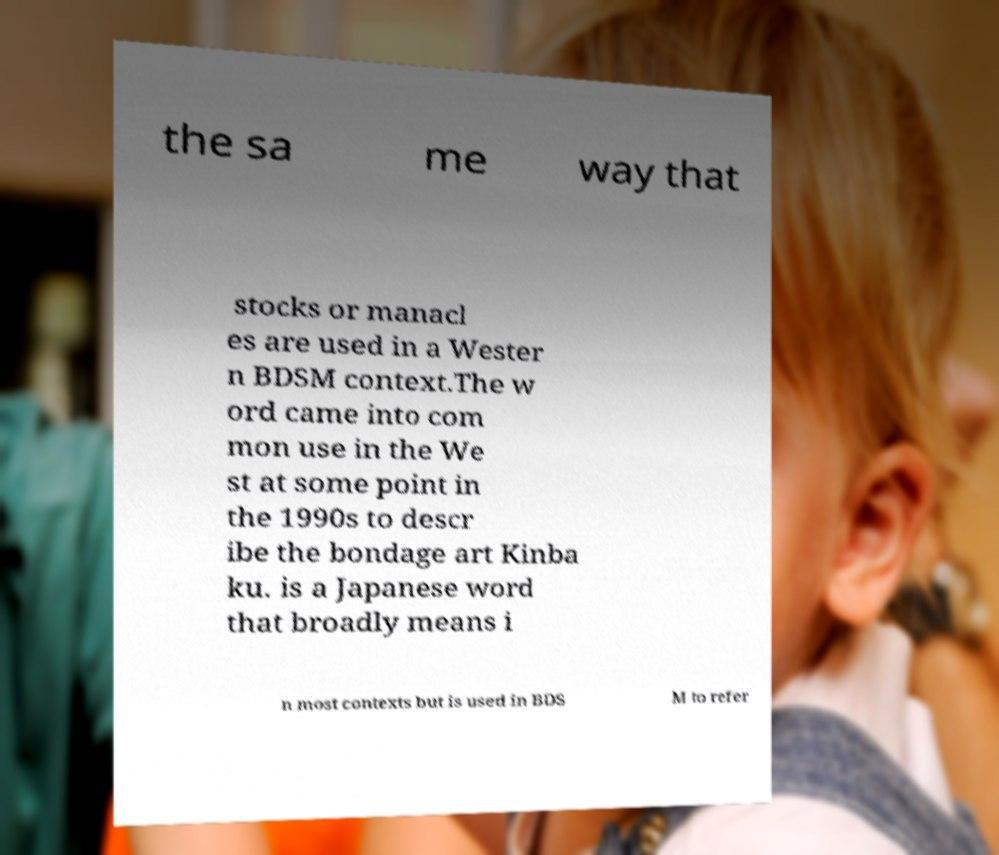Please read and relay the text visible in this image. What does it say? the sa me way that stocks or manacl es are used in a Wester n BDSM context.The w ord came into com mon use in the We st at some point in the 1990s to descr ibe the bondage art Kinba ku. is a Japanese word that broadly means i n most contexts but is used in BDS M to refer 